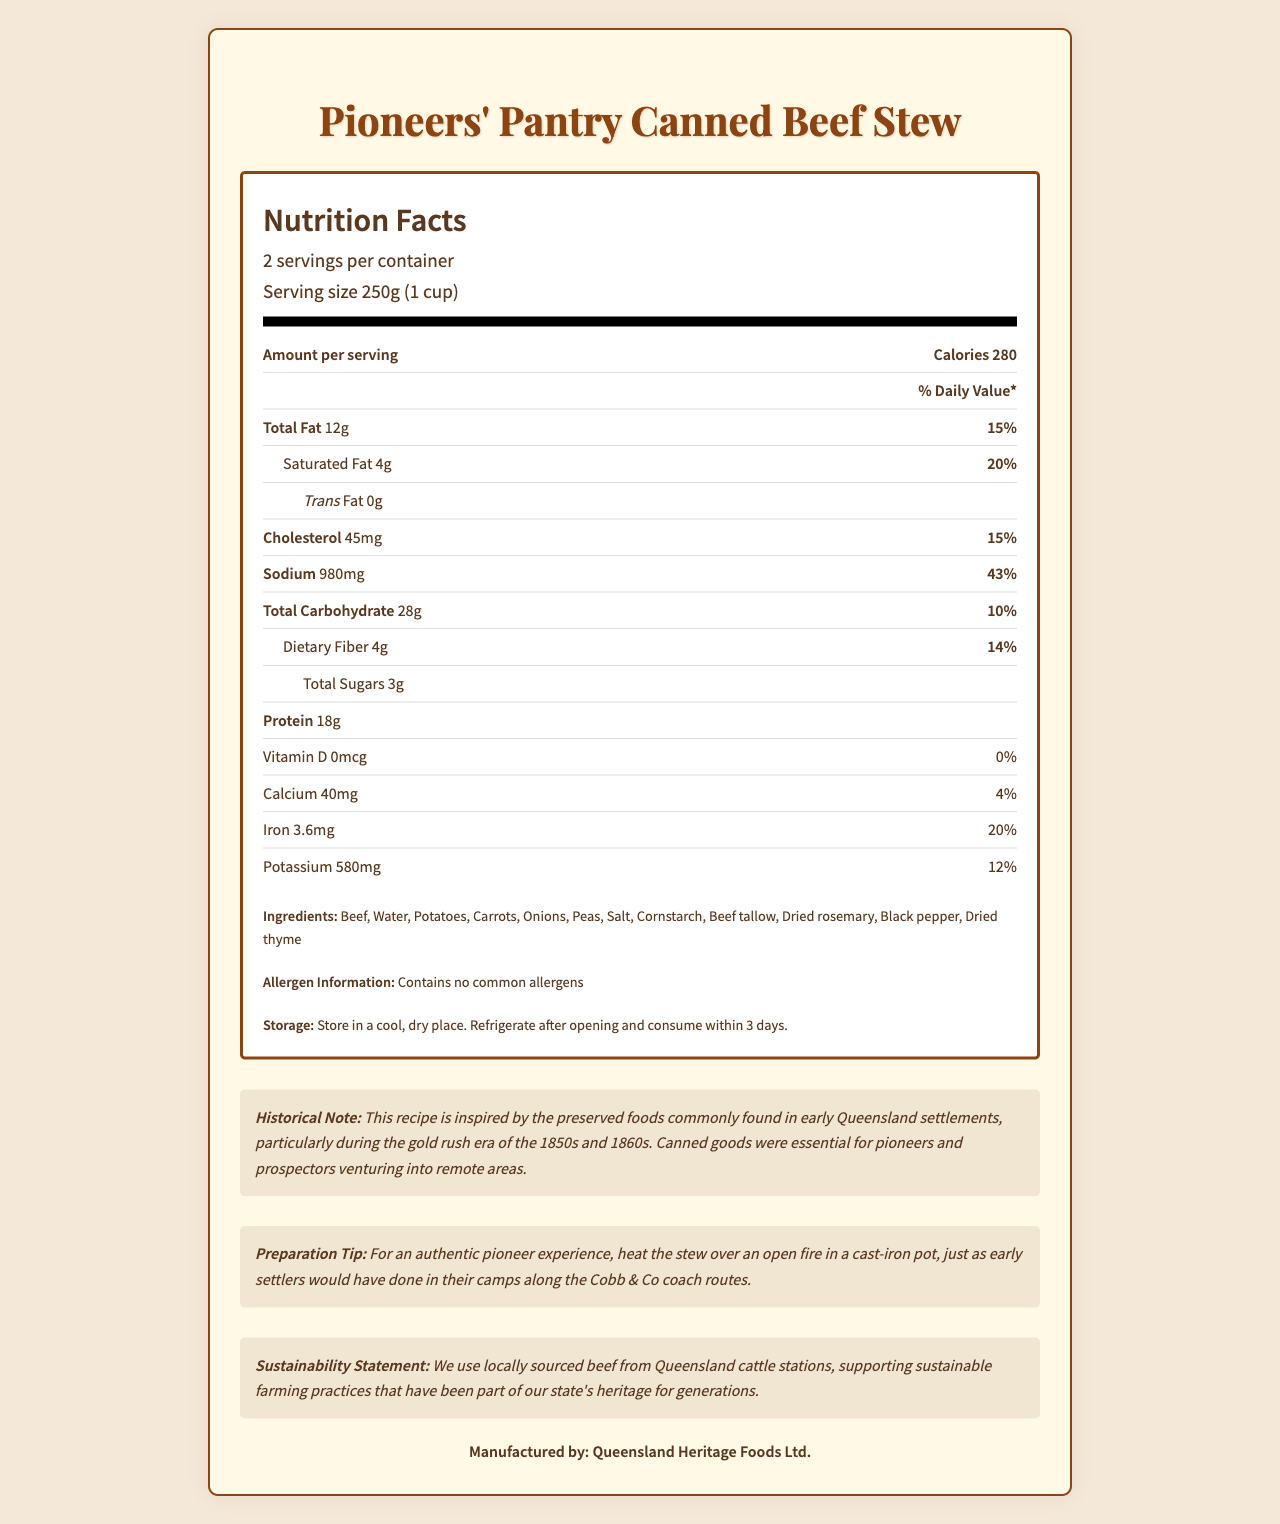what is the serving size of Pioneers' Pantry Canned Beef Stew? The serving size is specified in the nutrition label section of the document.
Answer: 250g (1 cup) how many servings are in each container of the beef stew? The document states that there are 2 servings per container.
Answer: 2 how many calories are in one serving of the beef stew? The amount of calories per serving is clearly mentioned in the bold nutrition item section.
Answer: 280 what is the total fat content in one serving? The total fat content per serving is listed among the nutrition facts.
Answer: 12g what percentage of the daily value is the sodium content? The percentage of the daily value for sodium is listed next to the amount of sodium in each serving.
Answer: 43% what are the main ingredients of the beef stew? A. Beef, Water, Potatoes, Carrots B. Beef, Water, Rice, Beans C. Chicken, Water, Potatoes, Carrots D. Beef, Milk, Potatoes, Peas According to the ingredients list in the document, the main ingredients are Beef, Water, Potatoes, Carrots, among others.
Answer: A. Beef, Water, Potatoes, Carrots which of the following vitamins or minerals has the highest daily value percentage in one serving? A. Vitamin D B. Calcium C. Iron D. Potassium The daily value percentage for Iron is 20%, which is higher than the daily values for Vitamin D, Calcium, and Potassium listed in the document.
Answer: C. Iron does this product contain any common allergens? The allergen information section indicates that the product contains no common allergens.
Answer: No what historical era inspired the recipe for this beef stew? The historical note mentions that the recipe is inspired by preserved foods from the gold rush era of the 1850s and 1860s.
Answer: The gold rush era of the 1850s and 1860s where is the beef for this product sourced from? The sustainability statement mentions that locally sourced beef from Queensland cattle stations is used.
Answer: Queensland describe the main idea of this document. The document serves to inform consumers about the nutritional content and heritage of the beef stew, while highlighting its historical significance and sustainability practices.
Answer: The document provides detailed nutritional information for "Pioneers' Pantry Canned Beef Stew," including serving size, calorie count, and nutrient values. It also lists the ingredients, storage instructions, and allergen info. Additionally, the document contains a historical note on the inspiration for the recipe, a preparation tip, a sustainability statement, and the manufacturer details. does the document mention the vitamin D content in each serving? The nutrition label specifies that the vitamin D content per serving is 0mcg and that it provides 0% of the daily value.
Answer: Yes how many grams of dietary fiber are in one serving of the beef stew? The nutrition facts indicate that each serving contains 4g of dietary fiber.
Answer: 4g what is the recommended preparation method to experience this stew like early settlers? The preparation tip suggests heating the stew over an open fire in a cast-iron pot for an authentic pioneer experience.
Answer: Heat the stew over an open fire in a cast-iron pot. how many milligrams of potassium are there in one serving? The nutrition facts list potassium content as 580mg per serving.
Answer: 580mg what is the manufacturer of this beef stew? The manufacturer is mentioned at the bottom of the document.
Answer: Queensland Heritage Foods Ltd. how long should the stew be consumed after opening if refrigerated? The storage instructions advise to refrigerate after opening and consume within 3 days.
Answer: Within 3 days does the document specify if the product contains any trans fat? In the nutrition facts section, it is mentioned that the product contains 0g of trans fat.
Answer: Yes, it contains 0g of trans fat. what is the total carbohydrate content per serving? The nutrition label lists the total carbohydrate content as 28g per serving.
Answer: 28g which company manufactures the beef stew? The document provides this information clearly: Queensland Heritage Foods Ltd. Therefore, it's incorrect to say this question cannot be answered.
Answer: Cannot be determined 